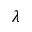<formula> <loc_0><loc_0><loc_500><loc_500>\lambda</formula> 